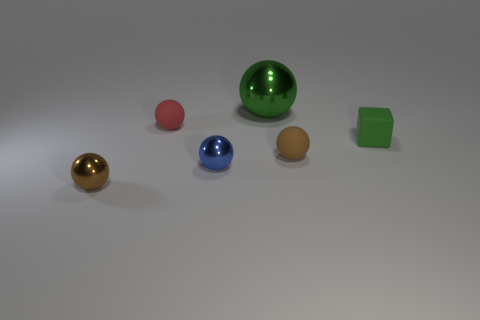Subtract 2 balls. How many balls are left? 3 Subtract all small brown matte balls. How many balls are left? 4 Subtract all red spheres. How many spheres are left? 4 Subtract all yellow balls. Subtract all yellow cylinders. How many balls are left? 5 Add 2 green metal cylinders. How many objects exist? 8 Subtract 1 red balls. How many objects are left? 5 Subtract all balls. How many objects are left? 1 Subtract all tiny purple shiny things. Subtract all blue things. How many objects are left? 5 Add 4 small red spheres. How many small red spheres are left? 5 Add 1 tiny matte spheres. How many tiny matte spheres exist? 3 